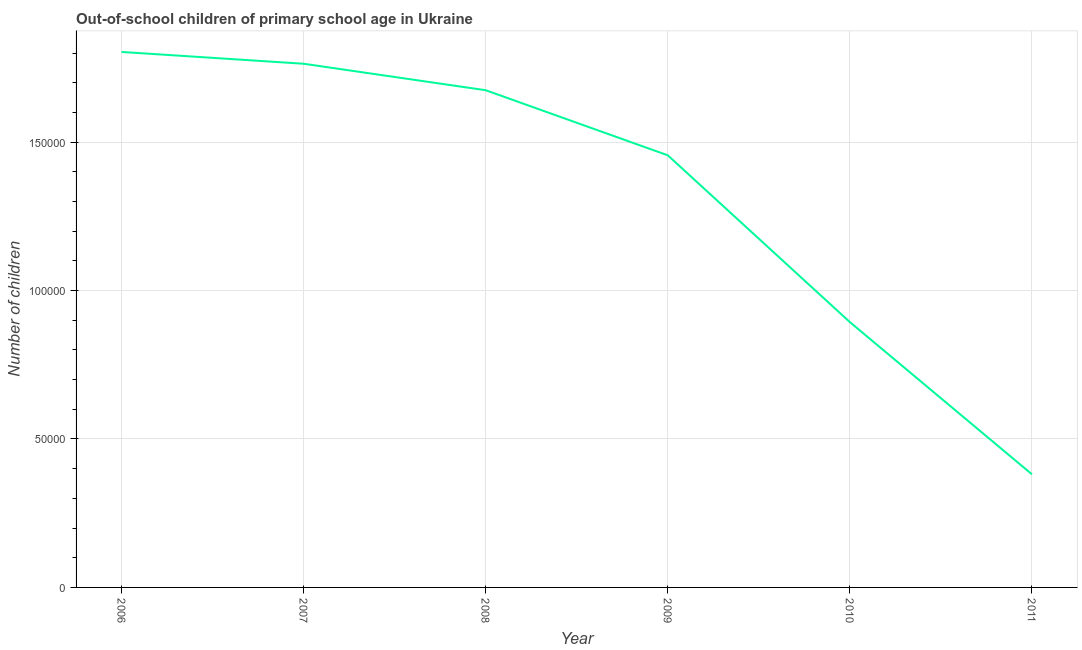What is the number of out-of-school children in 2007?
Provide a short and direct response. 1.76e+05. Across all years, what is the maximum number of out-of-school children?
Offer a very short reply. 1.80e+05. Across all years, what is the minimum number of out-of-school children?
Keep it short and to the point. 3.81e+04. In which year was the number of out-of-school children maximum?
Ensure brevity in your answer.  2006. What is the sum of the number of out-of-school children?
Give a very brief answer. 7.97e+05. What is the difference between the number of out-of-school children in 2006 and 2009?
Your answer should be very brief. 3.48e+04. What is the average number of out-of-school children per year?
Your answer should be compact. 1.33e+05. What is the median number of out-of-school children?
Keep it short and to the point. 1.57e+05. In how many years, is the number of out-of-school children greater than 50000 ?
Give a very brief answer. 5. Do a majority of the years between 2011 and 2008 (inclusive) have number of out-of-school children greater than 150000 ?
Provide a short and direct response. Yes. What is the ratio of the number of out-of-school children in 2008 to that in 2010?
Give a very brief answer. 1.87. Is the difference between the number of out-of-school children in 2008 and 2010 greater than the difference between any two years?
Your answer should be very brief. No. What is the difference between the highest and the second highest number of out-of-school children?
Provide a short and direct response. 3975. Is the sum of the number of out-of-school children in 2007 and 2009 greater than the maximum number of out-of-school children across all years?
Offer a terse response. Yes. What is the difference between the highest and the lowest number of out-of-school children?
Provide a short and direct response. 1.42e+05. How many lines are there?
Keep it short and to the point. 1. How many years are there in the graph?
Your answer should be compact. 6. Does the graph contain any zero values?
Provide a succinct answer. No. What is the title of the graph?
Provide a short and direct response. Out-of-school children of primary school age in Ukraine. What is the label or title of the Y-axis?
Your response must be concise. Number of children. What is the Number of children in 2006?
Provide a short and direct response. 1.80e+05. What is the Number of children in 2007?
Your response must be concise. 1.76e+05. What is the Number of children in 2008?
Keep it short and to the point. 1.67e+05. What is the Number of children of 2009?
Provide a short and direct response. 1.46e+05. What is the Number of children of 2010?
Your response must be concise. 8.94e+04. What is the Number of children of 2011?
Offer a terse response. 3.81e+04. What is the difference between the Number of children in 2006 and 2007?
Your answer should be compact. 3975. What is the difference between the Number of children in 2006 and 2008?
Make the answer very short. 1.29e+04. What is the difference between the Number of children in 2006 and 2009?
Keep it short and to the point. 3.48e+04. What is the difference between the Number of children in 2006 and 2010?
Your response must be concise. 9.10e+04. What is the difference between the Number of children in 2006 and 2011?
Keep it short and to the point. 1.42e+05. What is the difference between the Number of children in 2007 and 2008?
Provide a short and direct response. 8920. What is the difference between the Number of children in 2007 and 2009?
Offer a terse response. 3.08e+04. What is the difference between the Number of children in 2007 and 2010?
Provide a succinct answer. 8.70e+04. What is the difference between the Number of children in 2007 and 2011?
Make the answer very short. 1.38e+05. What is the difference between the Number of children in 2008 and 2009?
Your response must be concise. 2.19e+04. What is the difference between the Number of children in 2008 and 2010?
Provide a short and direct response. 7.81e+04. What is the difference between the Number of children in 2008 and 2011?
Ensure brevity in your answer.  1.29e+05. What is the difference between the Number of children in 2009 and 2010?
Give a very brief answer. 5.62e+04. What is the difference between the Number of children in 2009 and 2011?
Your answer should be compact. 1.07e+05. What is the difference between the Number of children in 2010 and 2011?
Provide a short and direct response. 5.13e+04. What is the ratio of the Number of children in 2006 to that in 2007?
Offer a terse response. 1.02. What is the ratio of the Number of children in 2006 to that in 2008?
Offer a terse response. 1.08. What is the ratio of the Number of children in 2006 to that in 2009?
Offer a very short reply. 1.24. What is the ratio of the Number of children in 2006 to that in 2010?
Offer a very short reply. 2.02. What is the ratio of the Number of children in 2006 to that in 2011?
Ensure brevity in your answer.  4.74. What is the ratio of the Number of children in 2007 to that in 2008?
Ensure brevity in your answer.  1.05. What is the ratio of the Number of children in 2007 to that in 2009?
Your response must be concise. 1.21. What is the ratio of the Number of children in 2007 to that in 2010?
Ensure brevity in your answer.  1.97. What is the ratio of the Number of children in 2007 to that in 2011?
Offer a terse response. 4.63. What is the ratio of the Number of children in 2008 to that in 2009?
Your answer should be very brief. 1.15. What is the ratio of the Number of children in 2008 to that in 2010?
Offer a terse response. 1.87. What is the ratio of the Number of children in 2008 to that in 2011?
Your answer should be very brief. 4.4. What is the ratio of the Number of children in 2009 to that in 2010?
Offer a terse response. 1.63. What is the ratio of the Number of children in 2009 to that in 2011?
Your response must be concise. 3.82. What is the ratio of the Number of children in 2010 to that in 2011?
Keep it short and to the point. 2.35. 